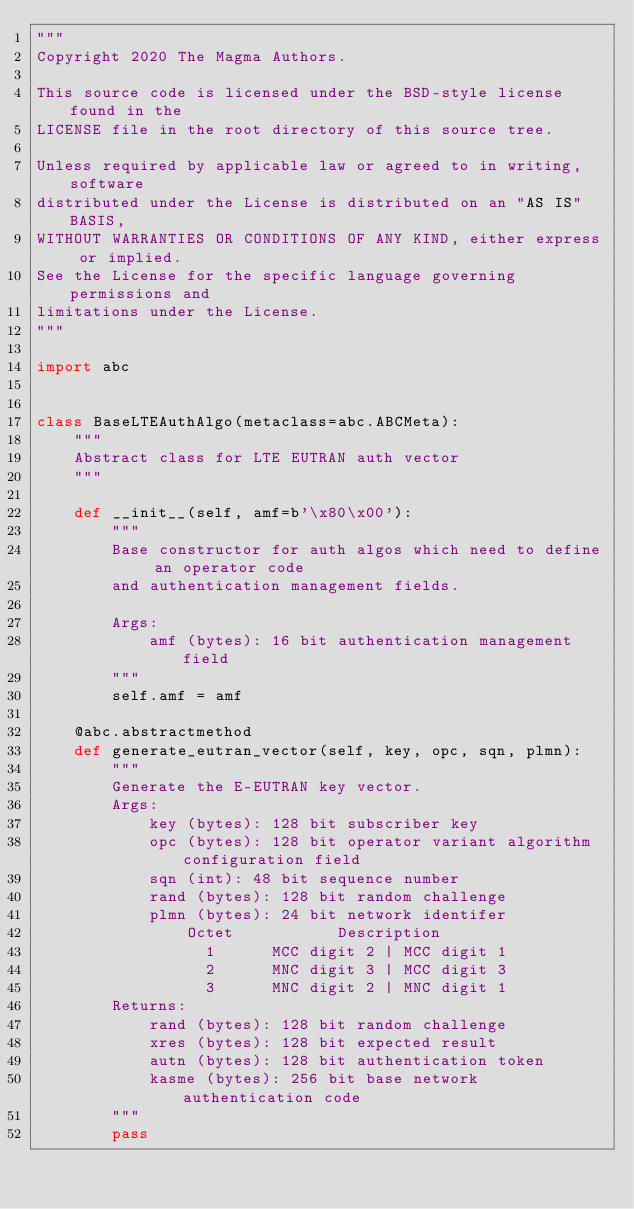<code> <loc_0><loc_0><loc_500><loc_500><_Python_>"""
Copyright 2020 The Magma Authors.

This source code is licensed under the BSD-style license found in the
LICENSE file in the root directory of this source tree.

Unless required by applicable law or agreed to in writing, software
distributed under the License is distributed on an "AS IS" BASIS,
WITHOUT WARRANTIES OR CONDITIONS OF ANY KIND, either express or implied.
See the License for the specific language governing permissions and
limitations under the License.
"""

import abc


class BaseLTEAuthAlgo(metaclass=abc.ABCMeta):
    """
    Abstract class for LTE EUTRAN auth vector
    """

    def __init__(self, amf=b'\x80\x00'):
        """
        Base constructor for auth algos which need to define an operator code
        and authentication management fields.

        Args:
            amf (bytes): 16 bit authentication management field
        """
        self.amf = amf

    @abc.abstractmethod
    def generate_eutran_vector(self, key, opc, sqn, plmn):
        """
        Generate the E-EUTRAN key vector.
        Args:
            key (bytes): 128 bit subscriber key
            opc (bytes): 128 bit operator variant algorithm configuration field            
            sqn (int): 48 bit sequence number
            rand (bytes): 128 bit random challenge
            plmn (bytes): 24 bit network identifer
                Octet           Description
                  1      MCC digit 2 | MCC digit 1
                  2      MNC digit 3 | MCC digit 3
                  3      MNC digit 2 | MNC digit 1
        Returns:
            rand (bytes): 128 bit random challenge
            xres (bytes): 128 bit expected result
            autn (bytes): 128 bit authentication token
            kasme (bytes): 256 bit base network authentication code
        """
        pass
</code> 